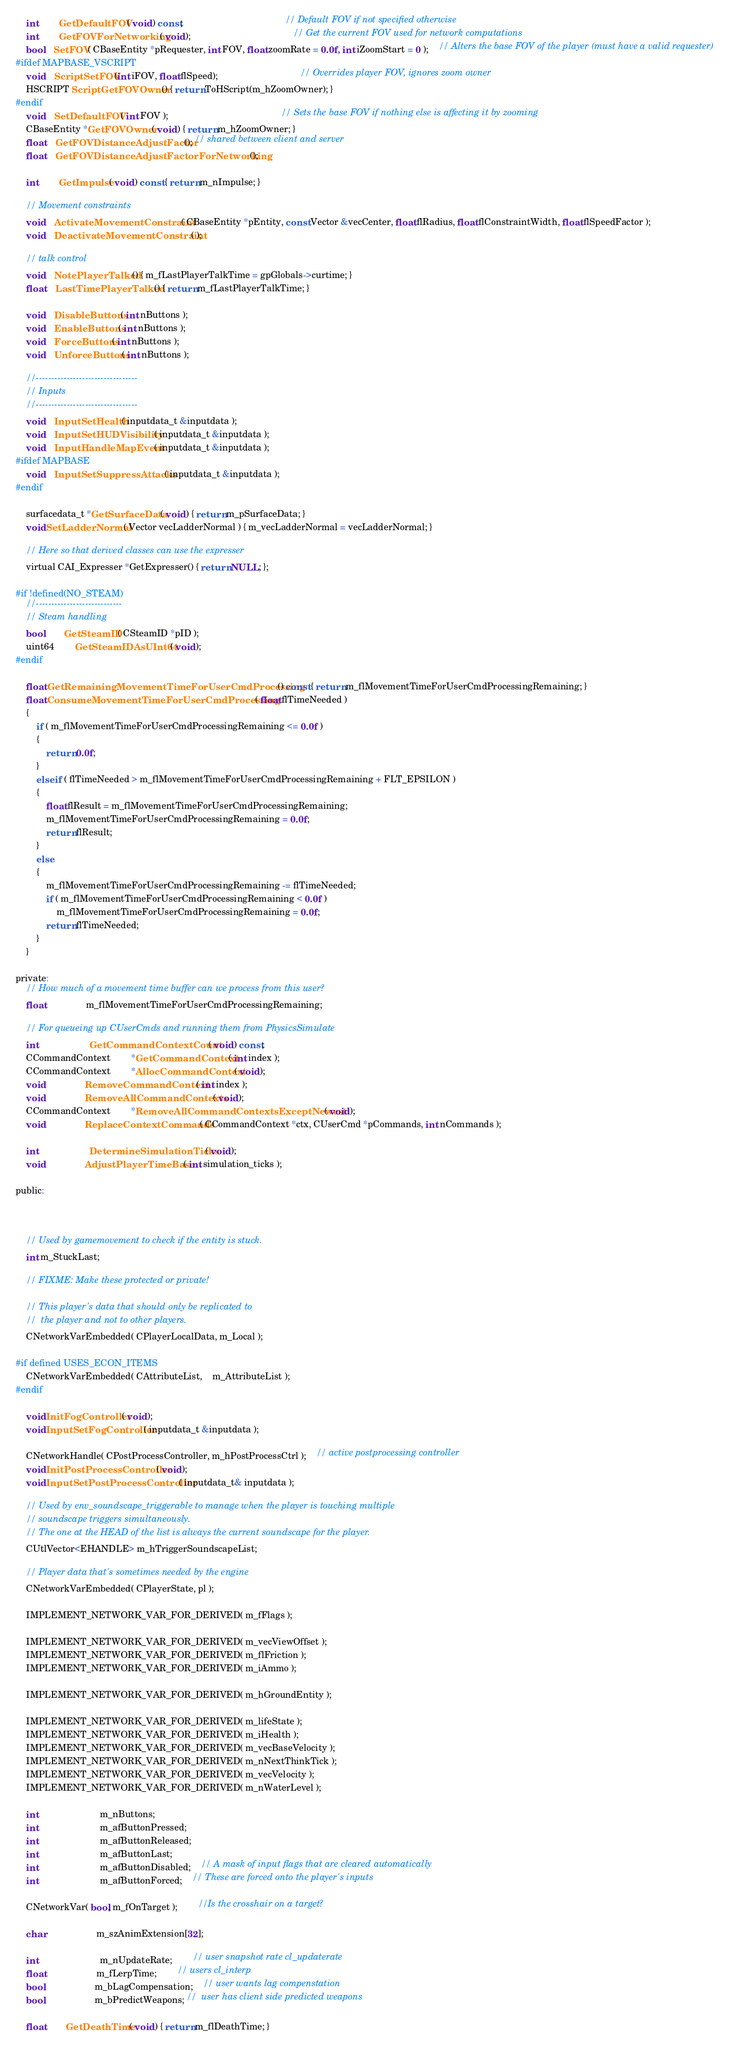Convert code to text. <code><loc_0><loc_0><loc_500><loc_500><_C_>	int		GetDefaultFOV( void ) const;										// Default FOV if not specified otherwise
	int		GetFOVForNetworking( void );										// Get the current FOV used for network computations
	bool	SetFOV( CBaseEntity *pRequester, int FOV, float zoomRate = 0.0f, int iZoomStart = 0 );	// Alters the base FOV of the player (must have a valid requester)
#ifdef MAPBASE_VSCRIPT
	void	ScriptSetFOV(int iFOV, float flSpeed);								// Overrides player FOV, ignores zoom owner
	HSCRIPT ScriptGetFOVOwner() { return ToHScript(m_hZoomOwner); }
#endif
	void	SetDefaultFOV( int FOV );											// Sets the base FOV if nothing else is affecting it by zooming
	CBaseEntity *GetFOVOwner( void ) { return m_hZoomOwner; }
	float	GetFOVDistanceAdjustFactor(); // shared between client and server
	float	GetFOVDistanceAdjustFactorForNetworking();

	int		GetImpulse( void ) const { return m_nImpulse; }

	// Movement constraints
	void	ActivateMovementConstraint( CBaseEntity *pEntity, const Vector &vecCenter, float flRadius, float flConstraintWidth, float flSpeedFactor );
	void	DeactivateMovementConstraint( );

	// talk control
	void	NotePlayerTalked() { m_fLastPlayerTalkTime = gpGlobals->curtime; }
	float	LastTimePlayerTalked() { return m_fLastPlayerTalkTime; }

	void	DisableButtons( int nButtons );
	void	EnableButtons( int nButtons );
	void	ForceButtons( int nButtons );
	void	UnforceButtons( int nButtons );

	//---------------------------------
	// Inputs
	//---------------------------------
	void	InputSetHealth( inputdata_t &inputdata );
	void	InputSetHUDVisibility( inputdata_t &inputdata );
	void	InputHandleMapEvent( inputdata_t &inputdata );
#ifdef MAPBASE
	void	InputSetSuppressAttacks( inputdata_t &inputdata );
#endif

	surfacedata_t *GetSurfaceData( void ) { return m_pSurfaceData; }
	void SetLadderNormal( Vector vecLadderNormal ) { m_vecLadderNormal = vecLadderNormal; }

	// Here so that derived classes can use the expresser
	virtual CAI_Expresser *GetExpresser() { return NULL; };

#if !defined(NO_STEAM)
	//----------------------------
	// Steam handling
	bool		GetSteamID( CSteamID *pID );
	uint64		GetSteamIDAsUInt64( void );
#endif

	float GetRemainingMovementTimeForUserCmdProcessing() const { return m_flMovementTimeForUserCmdProcessingRemaining; }
	float ConsumeMovementTimeForUserCmdProcessing( float flTimeNeeded )
	{
		if ( m_flMovementTimeForUserCmdProcessingRemaining <= 0.0f )
		{
			return 0.0f;
		}
		else if ( flTimeNeeded > m_flMovementTimeForUserCmdProcessingRemaining + FLT_EPSILON )
		{
			float flResult = m_flMovementTimeForUserCmdProcessingRemaining;
			m_flMovementTimeForUserCmdProcessingRemaining = 0.0f;
			return flResult;
		}
		else
		{
			m_flMovementTimeForUserCmdProcessingRemaining -= flTimeNeeded;
			if ( m_flMovementTimeForUserCmdProcessingRemaining < 0.0f )
				m_flMovementTimeForUserCmdProcessingRemaining = 0.0f;
			return flTimeNeeded;
		}
	}

private:
	// How much of a movement time buffer can we process from this user?
	float				m_flMovementTimeForUserCmdProcessingRemaining;

	// For queueing up CUserCmds and running them from PhysicsSimulate
	int					GetCommandContextCount( void ) const;
	CCommandContext		*GetCommandContext( int index );
	CCommandContext		*AllocCommandContext( void );
	void				RemoveCommandContext( int index );
	void				RemoveAllCommandContexts( void );
	CCommandContext		*RemoveAllCommandContextsExceptNewest( void );
	void				ReplaceContextCommands( CCommandContext *ctx, CUserCmd *pCommands, int nCommands );

	int					DetermineSimulationTicks( void );
	void				AdjustPlayerTimeBase( int simulation_ticks );

public:
	


	// Used by gamemovement to check if the entity is stuck.
	int m_StuckLast;
	
	// FIXME: Make these protected or private!

	// This player's data that should only be replicated to 
	//  the player and not to other players.
	CNetworkVarEmbedded( CPlayerLocalData, m_Local );

#if defined USES_ECON_ITEMS
	CNetworkVarEmbedded( CAttributeList,	m_AttributeList );
#endif

	void InitFogController( void );
	void InputSetFogController( inputdata_t &inputdata );

	CNetworkHandle( CPostProcessController, m_hPostProcessCtrl );	// active postprocessing controller
	void InitPostProcessController( void );
	void InputSetPostProcessController( inputdata_t& inputdata );

	// Used by env_soundscape_triggerable to manage when the player is touching multiple
	// soundscape triggers simultaneously.
	// The one at the HEAD of the list is always the current soundscape for the player.
	CUtlVector<EHANDLE> m_hTriggerSoundscapeList;

	// Player data that's sometimes needed by the engine
	CNetworkVarEmbedded( CPlayerState, pl );

	IMPLEMENT_NETWORK_VAR_FOR_DERIVED( m_fFlags );

	IMPLEMENT_NETWORK_VAR_FOR_DERIVED( m_vecViewOffset );
	IMPLEMENT_NETWORK_VAR_FOR_DERIVED( m_flFriction );
	IMPLEMENT_NETWORK_VAR_FOR_DERIVED( m_iAmmo );
	
	IMPLEMENT_NETWORK_VAR_FOR_DERIVED( m_hGroundEntity );

	IMPLEMENT_NETWORK_VAR_FOR_DERIVED( m_lifeState );
	IMPLEMENT_NETWORK_VAR_FOR_DERIVED( m_iHealth );
	IMPLEMENT_NETWORK_VAR_FOR_DERIVED( m_vecBaseVelocity );
	IMPLEMENT_NETWORK_VAR_FOR_DERIVED( m_nNextThinkTick );
	IMPLEMENT_NETWORK_VAR_FOR_DERIVED( m_vecVelocity );
	IMPLEMENT_NETWORK_VAR_FOR_DERIVED( m_nWaterLevel );
	
	int						m_nButtons;
	int						m_afButtonPressed;
	int						m_afButtonReleased;
	int						m_afButtonLast;
	int						m_afButtonDisabled;	// A mask of input flags that are cleared automatically
	int						m_afButtonForced;	// These are forced onto the player's inputs

	CNetworkVar( bool, m_fOnTarget );		//Is the crosshair on a target?

	char					m_szAnimExtension[32];

	int						m_nUpdateRate;		// user snapshot rate cl_updaterate
	float					m_fLerpTime;		// users cl_interp
	bool					m_bLagCompensation;	// user wants lag compenstation
	bool					m_bPredictWeapons; //  user has client side predicted weapons
	
	float		GetDeathTime( void ) { return m_flDeathTime; }
</code> 